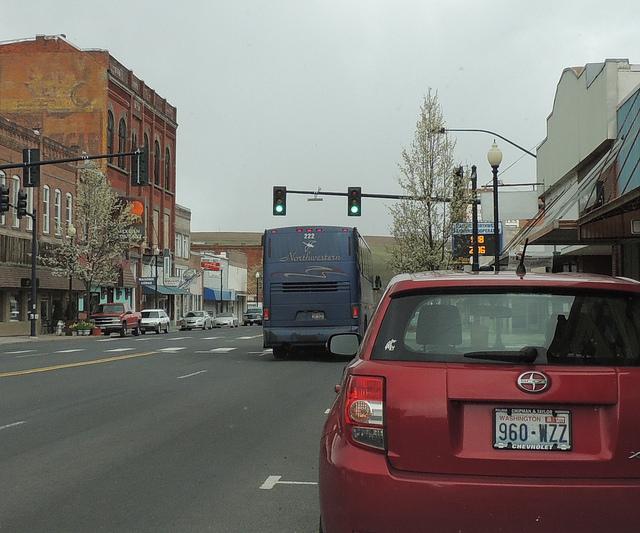What kind of town is this?
Keep it brief. City. What color is the signal light?
Be succinct. Green. Is the traffic light green?
Short answer required. Yes. What color is the car?
Quick response, please. Red. Is this photo in Europe?
Answer briefly. No. How many cars are on the street?
Keep it brief. 6. What animal is in the window?
Quick response, please. Dog. What is the license plate?
Give a very brief answer. 960-wzz. Is this a residential or business area?
Quick response, please. Business. How busy is the traffic?
Quick response, please. Not very. How many people in the van?
Answer briefly. 0. What are the traffic lights signaling?
Keep it brief. Go. What is the color of the car behind?
Keep it brief. Red. Is the light turning red?
Answer briefly. No. Is the car parked or in motion?
Keep it brief. Parked. What is the color of the bus?
Keep it brief. Blue. What color is the light?
Write a very short answer. Green. Does the car have a US license plate?
Write a very short answer. Yes. What color are the license plates that a visible?
Write a very short answer. White. What is the number next to the traffic light?
Short answer required. 960. 